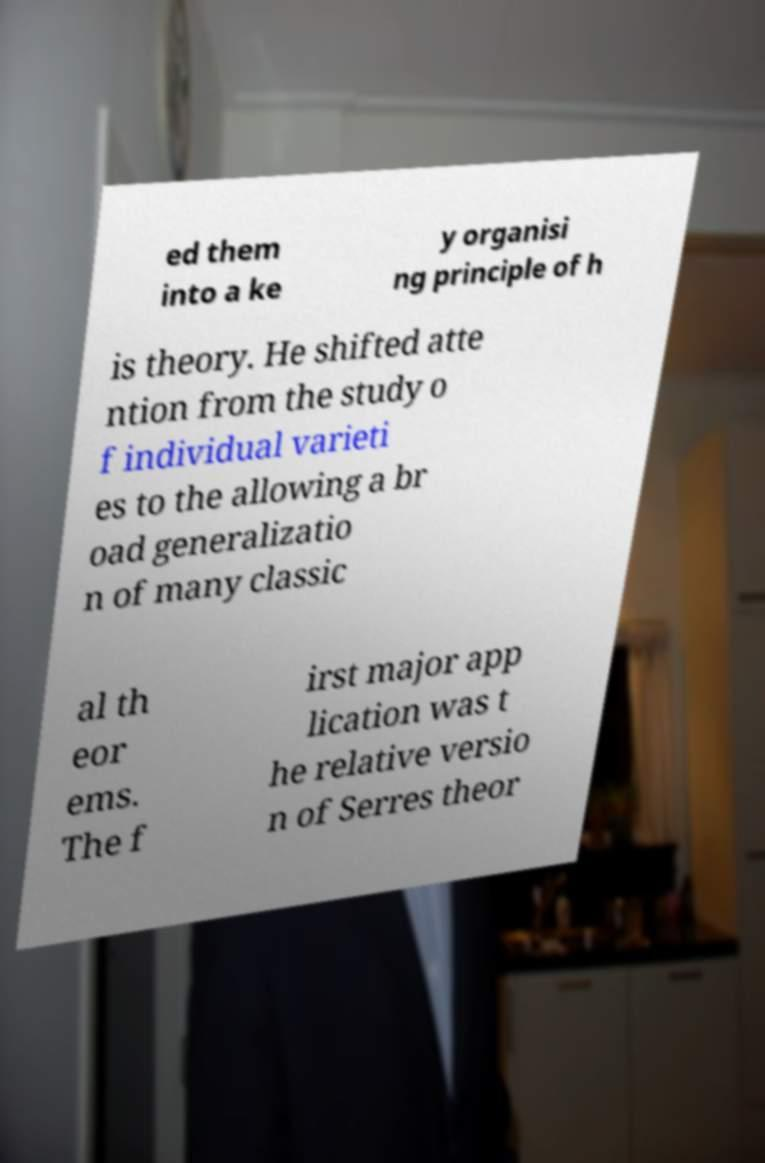There's text embedded in this image that I need extracted. Can you transcribe it verbatim? ed them into a ke y organisi ng principle of h is theory. He shifted atte ntion from the study o f individual varieti es to the allowing a br oad generalizatio n of many classic al th eor ems. The f irst major app lication was t he relative versio n of Serres theor 